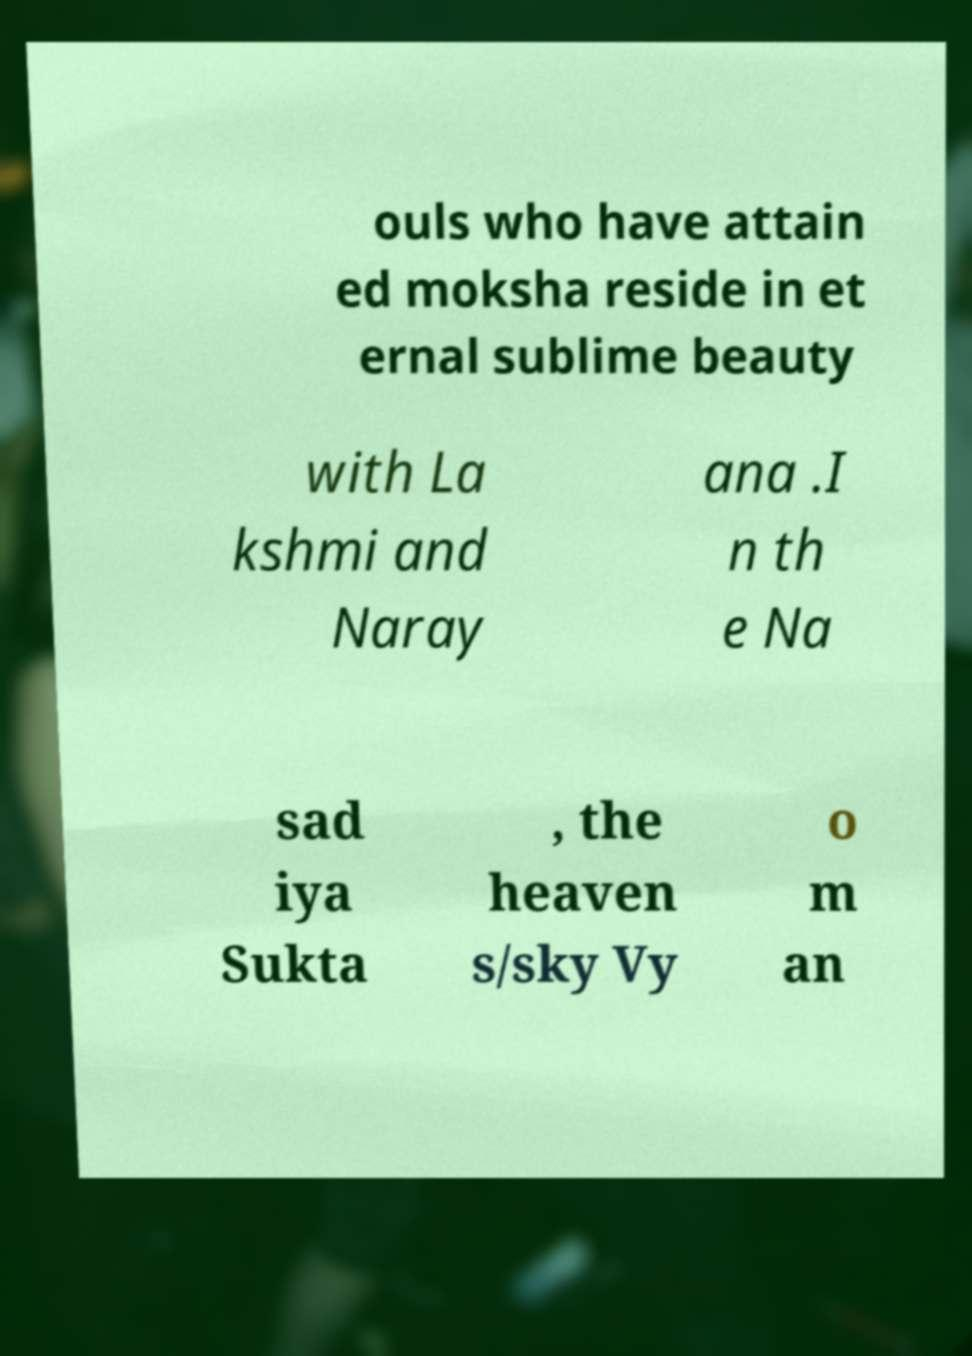For documentation purposes, I need the text within this image transcribed. Could you provide that? ouls who have attain ed moksha reside in et ernal sublime beauty with La kshmi and Naray ana .I n th e Na sad iya Sukta , the heaven s/sky Vy o m an 